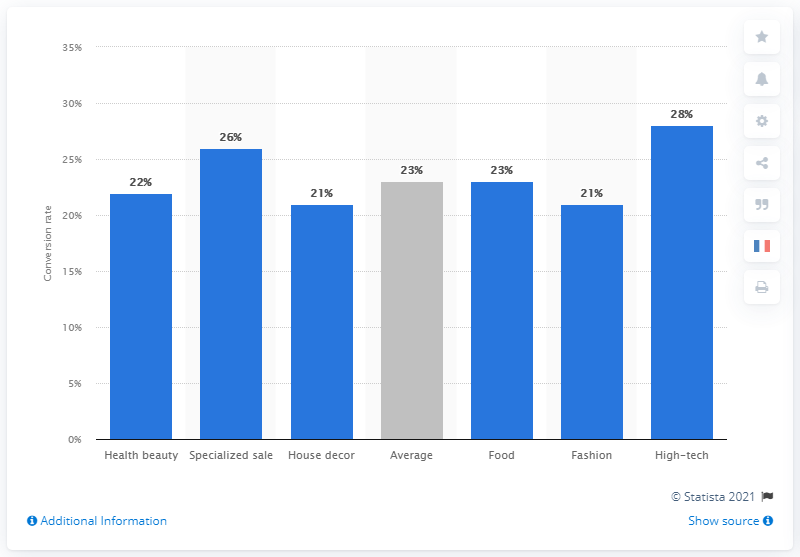Draw attention to some important aspects in this diagram. The conversion rate of e-commerce websites in the fashion sector during Q2 2016 was 21%. 